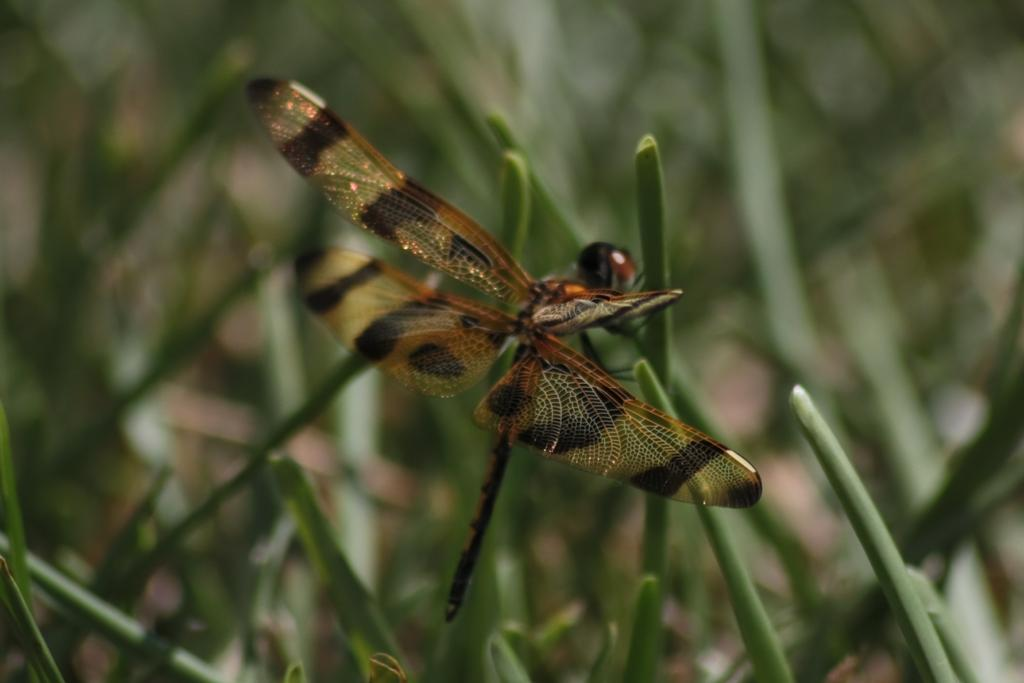What type of insect is present in the image? There is a dragonfly in the image. Can you describe the background of the image? The background of the image is blurred. What type of authority figure can be seen in the image? There is no authority figure present in the image; it features a dragonfly and a blurred background. What type of lock is visible on the dragonfly in the image? There is no lock present on the dragonfly in the image; it is a living insect. 